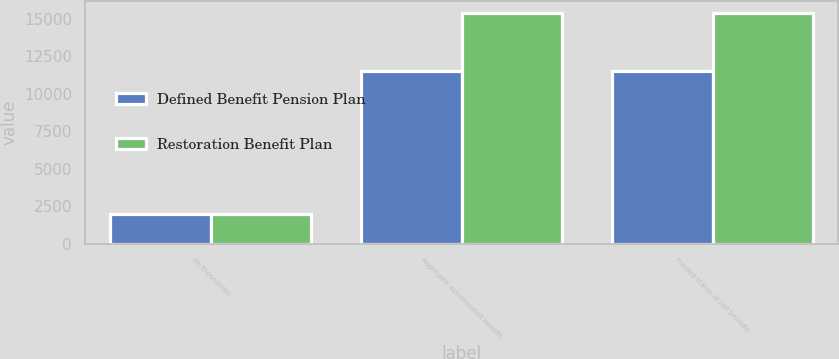<chart> <loc_0><loc_0><loc_500><loc_500><stacked_bar_chart><ecel><fcel>(in thousands)<fcel>Aggregate accumulated benefit<fcel>Funded status of net periodic<nl><fcel>Defined Benefit Pension Plan<fcel>2004<fcel>11496<fcel>11496<nl><fcel>Restoration Benefit Plan<fcel>2004<fcel>15416<fcel>15416<nl></chart> 